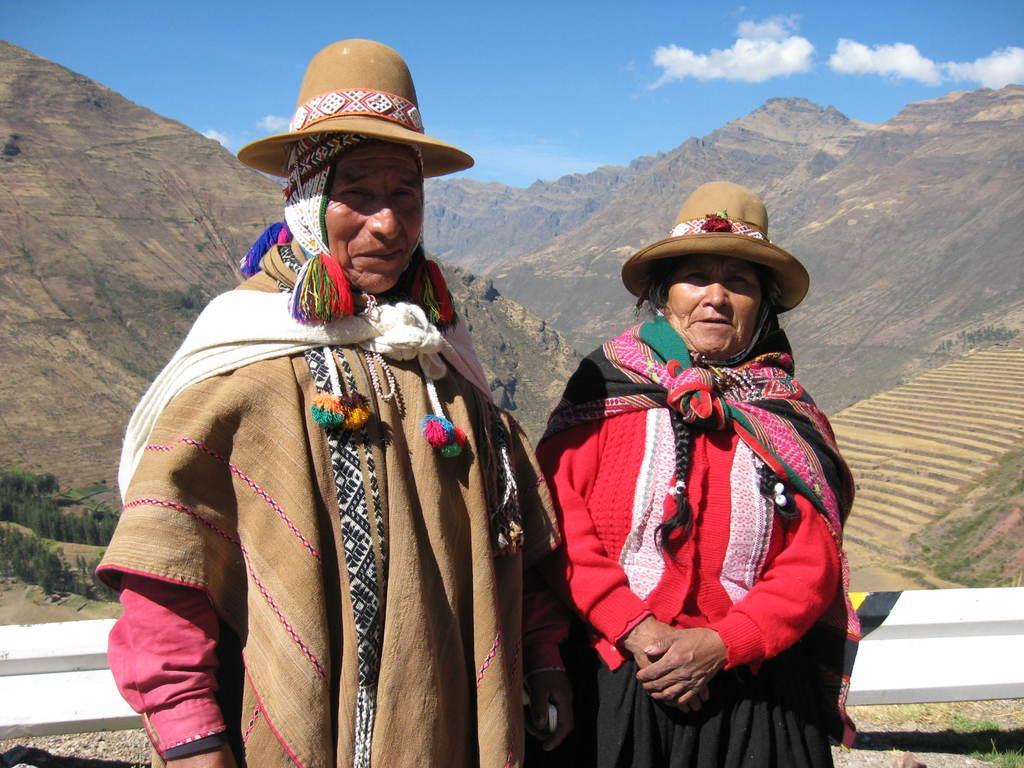In one or two sentences, can you explain what this image depicts? In this picture I can see a man and a woman standing and they wore caps on their heads and I can see hills and a blue cloudy sky and I can see trees. 